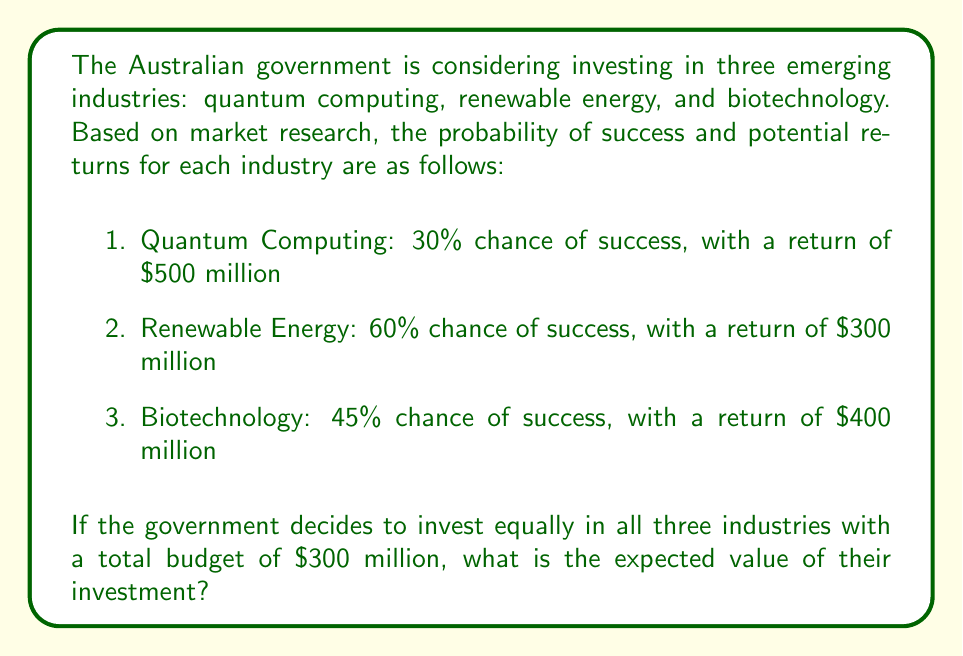What is the answer to this math problem? To solve this problem, we need to calculate the expected value of each investment and then sum them up. The expected value is calculated by multiplying the probability of success by the potential return.

Let's break it down step-by-step:

1. Calculate the investment amount for each industry:
   Total budget = $300 million
   Investment per industry = $300 million ÷ 3 = $100 million

2. Calculate the expected value for each industry:

   a) Quantum Computing:
      Probability of success = 30% = 0.3
      Potential return = $500 million
      Expected value = $500 million × 0.3 = $150 million

   b) Renewable Energy:
      Probability of success = 60% = 0.6
      Potential return = $300 million
      Expected value = $300 million × 0.6 = $180 million

   c) Biotechnology:
      Probability of success = 45% = 0.45
      Potential return = $400 million
      Expected value = $400 million × 0.45 = $180 million

3. Calculate the net expected value for each industry by subtracting the investment:

   a) Quantum Computing: $150 million - $100 million = $50 million
   b) Renewable Energy: $180 million - $100 million = $80 million
   c) Biotechnology: $180 million - $100 million = $80 million

4. Sum up the net expected values:

   Total net expected value = $50 million + $80 million + $80 million = $210 million

Therefore, the expected value of the government's investment in these emerging industries is $210 million.

We can express this mathematically as:

$$E[V] = \sum_{i=1}^{n} (p_i \times R_i - I_i)$$

Where:
$E[V]$ is the expected value
$n$ is the number of industries
$p_i$ is the probability of success for industry $i$
$R_i$ is the potential return for industry $i$
$I_i$ is the investment amount for industry $i$

Plugging in our values:

$$E[V] = (0.3 \times 500 - 100) + (0.6 \times 300 - 100) + (0.45 \times 400 - 100) = 210$$
Answer: $210 million 